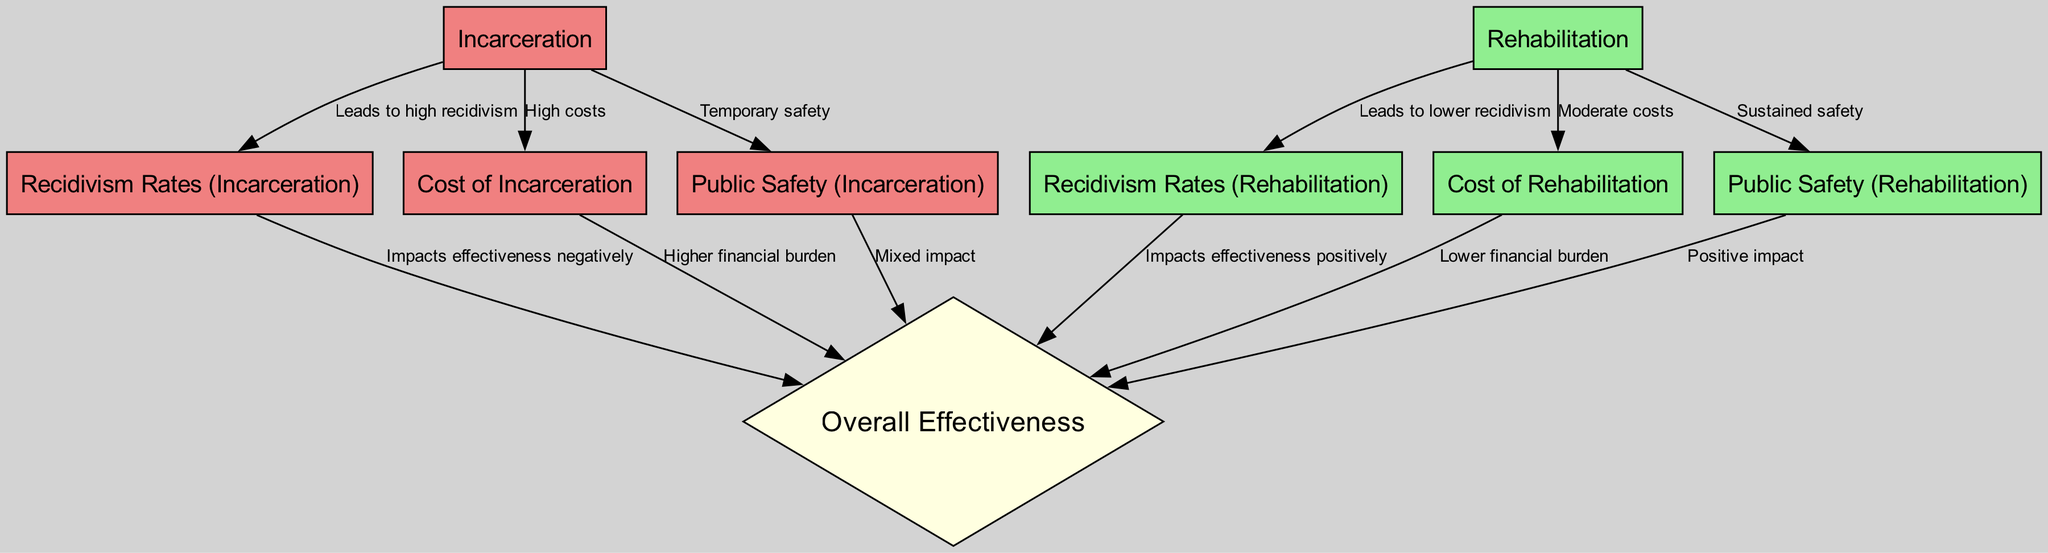What leads to high recidivism? The diagram shows that "Incarceration" leads to "Recidivism Rates (Incarceration)" which indicates a link to high recidivism.
Answer: Incarceration What are the costs associated with rehabilitation? According to the diagram, the "Cost of Rehabilitation" is indicated as "Moderate costs", directly reflecting the financial aspect of rehabilitation.
Answer: Moderate costs How does incarceration impact public safety? The diagram illustrates that "Public Safety (Incarceration)" is categorized as "Temporary safety", meaning the safety outcomes are only short-lived.
Answer: Temporary safety What is the relationship between rehabilitation and recidivism rates? The information presents that "Rehabilitation" leads to "Recidivism Rates (Rehabilitation)", which indicates that rehabilitation results in lower recidivism rates.
Answer: Lower recidivism Which approach impacts overall effectiveness positively? The flow in the diagram shows that "Recidivism Rates (Rehabilitation)" positively affects "Overall Effectiveness", suggesting that rehabilitation improves effectiveness.
Answer: Rehabilitation What is the connection between costs of incarceration and overall effectiveness? The diagram states that "Cost of Incarceration" leads to "Overall Effectiveness" and is described as causing a "Higher financial burden", indicating a negative correlation with effectiveness.
Answer: Higher financial burden How many edges are there in the diagram? By counting the connections (edges) shown between the nodes in the diagram, it can be determined that there are a total of 12 edges.
Answer: 12 What is the cost type associated with incarceration? The diagram specifies "Cost of Incarceration", which categorizes the financial aspect linked to incarceration as "High costs".
Answer: High costs Which factor leads to sustained safety? The diagram indicates that "Rehabilitation" leads to "Public Safety (Rehabilitation)", which is linked to "Sustained safety", highlighting the long-term safety outcomes of rehabilitation.
Answer: Sustained safety 